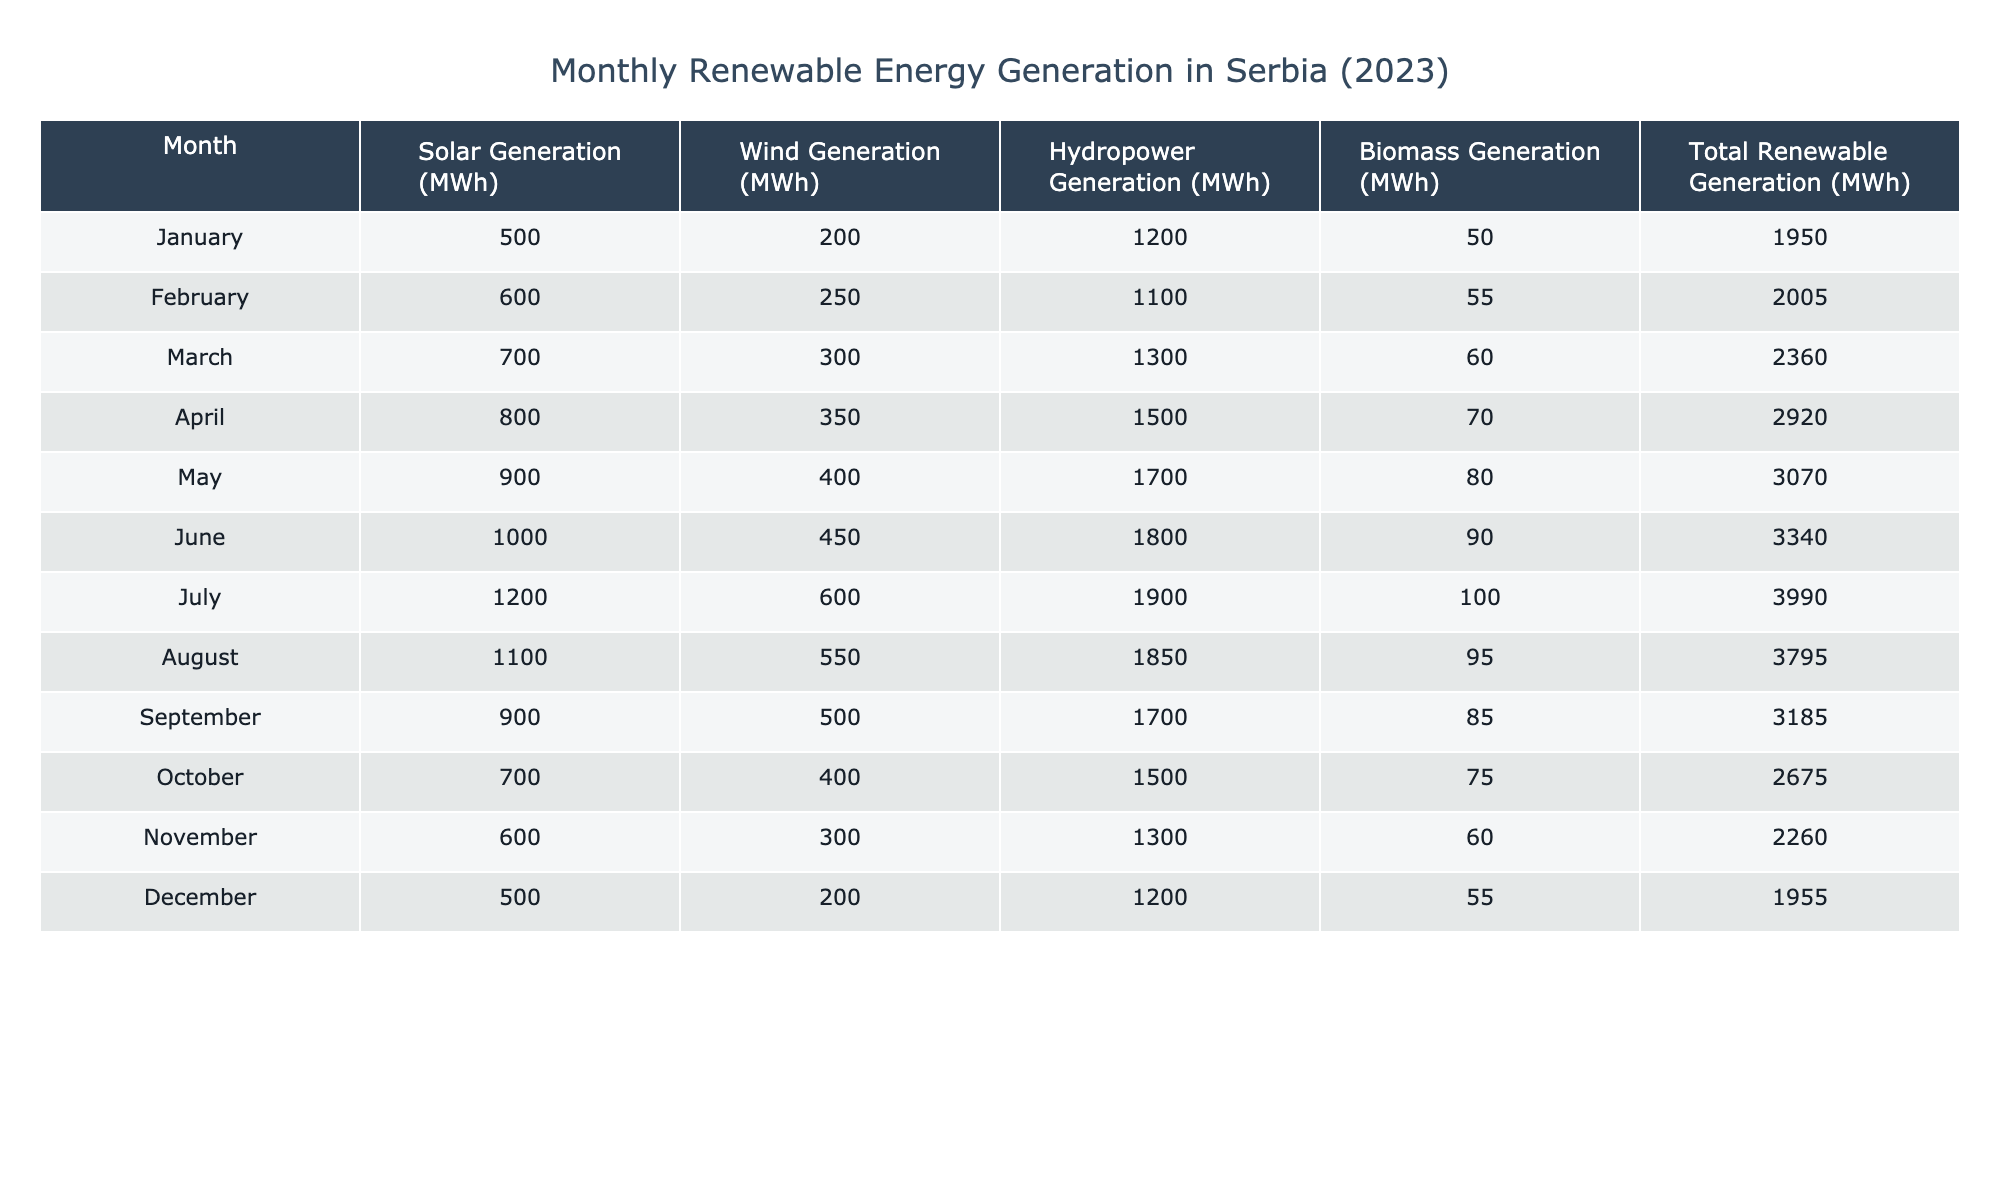What is the total renewable energy generation in July? The table shows the total renewable generation in July is 3990 MWh.
Answer: 3990 MWh What was the lowest solar generation recorded in 2023? The lowest solar generation in the table is 500 MWh, which occurred in January.
Answer: 500 MWh Which month had the highest wind generation and what was that value? The highest wind generation in the table is 600 MWh, recorded in July.
Answer: 600 MWh What is the difference in hydropower generation between March and November? In March, hydropower generation was 1300 MWh and in November, it was 1300 MWh. The difference is 1300 - 1300 = 0 MWh.
Answer: 0 MWh What is the average monthly biomass generation for the year? To find the average, first sum the biomass generation values: 50 + 55 + 60 + 70 + 80 + 90 + 100 + 95 + 85 + 75 + 60 + 55 = 1050 MWh. Then divide by the number of months (12): 1050 / 12 = 87.5 MWh.
Answer: 87.5 MWh Was there any month in 2023 where total renewable generation was less than 2000 MWh? Looking at the table, the total renewable generation was 1950 MWh in January and December, which is less than 2000 MWh.
Answer: Yes In which month did biomass generation exceed wind generation? By comparing the values, biomass generation exceeded wind generation in May (biomass 80 MWh, wind 400 MWh), but not in other months.
Answer: In May How much greater was total renewable generation in June compared to January? Total renewable generation in June was 3340 MWh and in January it was 1950 MWh. The difference is 3340 - 1950 = 1390 MWh.
Answer: 1390 MWh What percentage of total renewable generation in April was contributed by hydropower? In April, the total renewable generation was 2920 MWh and hydropower generation was 1500 MWh. The percentage is (1500 / 2920) * 100 = 51.37%.
Answer: 51.37% 